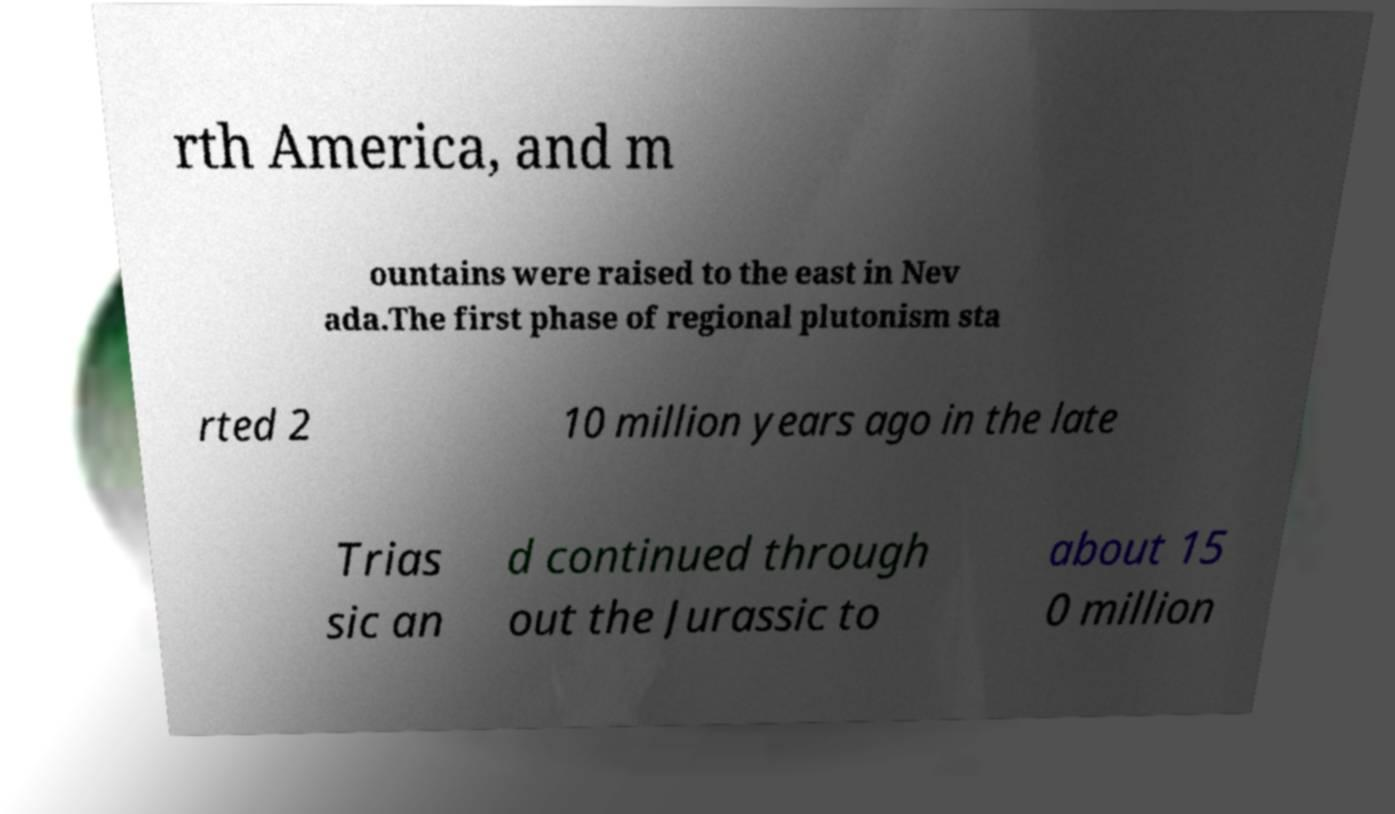There's text embedded in this image that I need extracted. Can you transcribe it verbatim? rth America, and m ountains were raised to the east in Nev ada.The first phase of regional plutonism sta rted 2 10 million years ago in the late Trias sic an d continued through out the Jurassic to about 15 0 million 